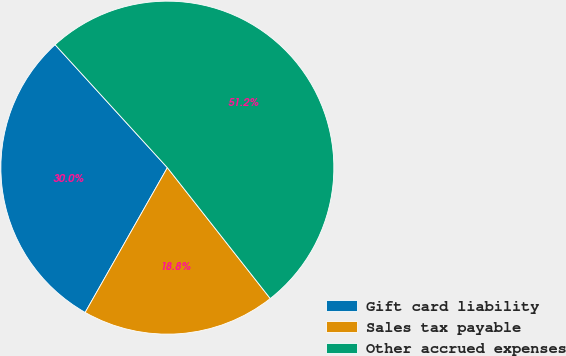Convert chart to OTSL. <chart><loc_0><loc_0><loc_500><loc_500><pie_chart><fcel>Gift card liability<fcel>Sales tax payable<fcel>Other accrued expenses<nl><fcel>30.0%<fcel>18.82%<fcel>51.17%<nl></chart> 